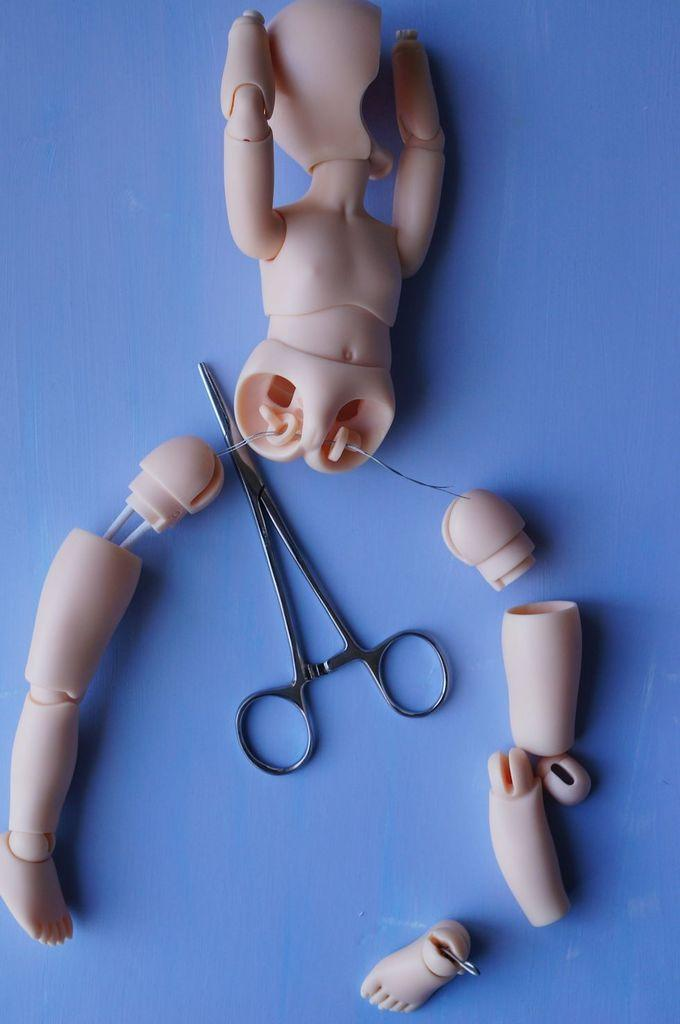What type of object is shown in pieces in the image? There are parts of a toy in the image. What tool is visible in the image? There are scissors in the image. What color is the background of the image? The background color is blue. Can you tell me how many yaks are present in the image? There are no yaks present in the image. What advice does the grandmother give to the mother in the image? There is no grandmother or mother present in the image, so it is not possible to answer that question. 